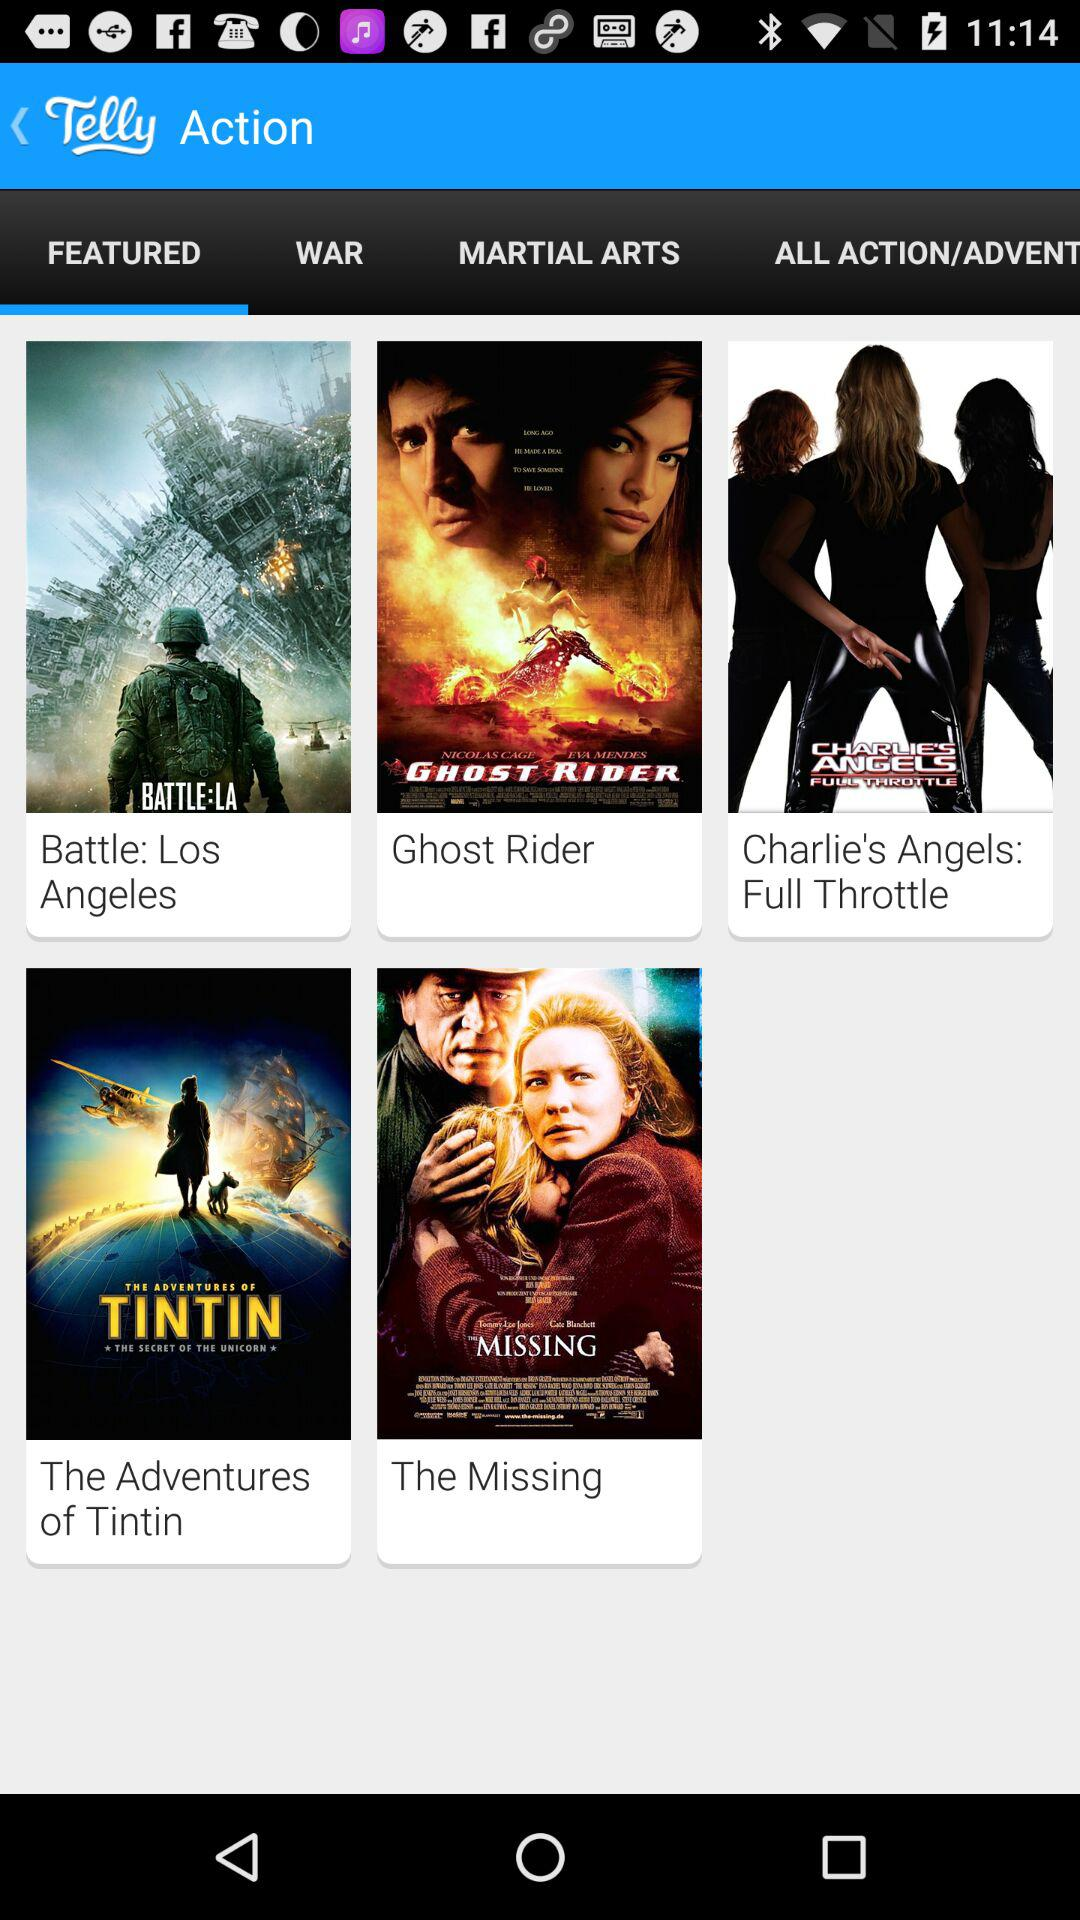Which tab is open? The tab "FEATURED" is open. 